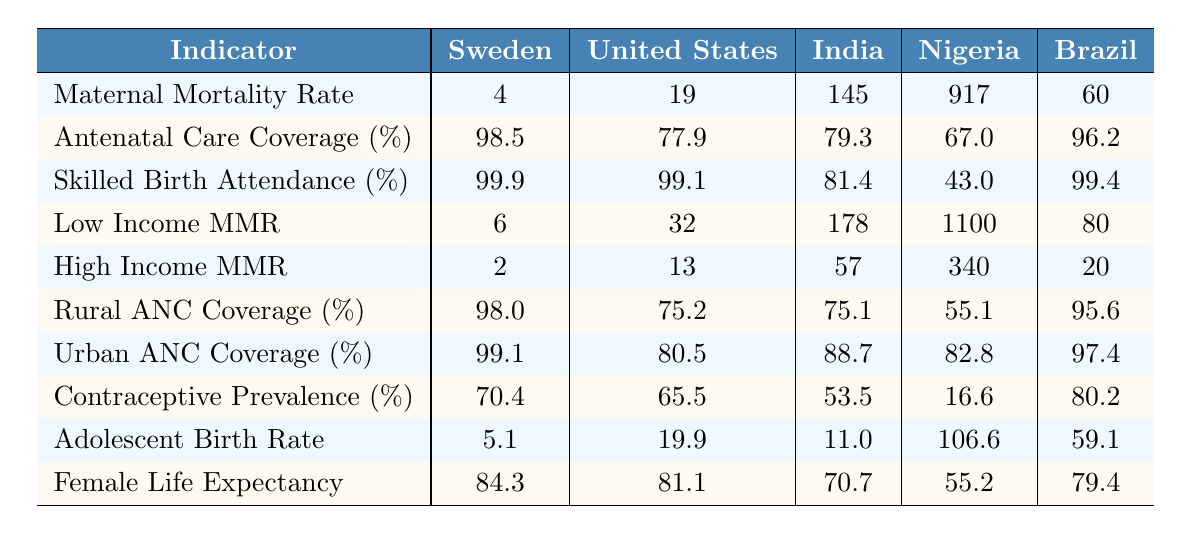What is the maternal mortality rate in Sweden? The table shows that Sweden's maternal mortality rate is listed as 4.
Answer: 4 Which country has the highest antenatal care coverage? Looking at the table, Sweden has the highest antenatal care coverage at 98.5%.
Answer: Sweden What is the percentage of skilled birth attendance in Nigeria? According to the table, Nigeria has a skilled birth attendance percentage of 43.0%.
Answer: 43.0% What is the difference in maternal mortality rate between India and Brazil? India's maternal mortality rate is 145 and Brazil's is 60. The difference is 145 - 60 = 85.
Answer: 85 Is the low-income maternal mortality rate in the United States higher than that in Sweden? The low-income maternal mortality rate in the United States is 32, while Sweden's is 6. Since 32 is greater than 6, the statement is true.
Answer: Yes Which country has the lowest maternal mortality rate, and how does it compare with Nigeria? Sweden has the lowest maternal mortality rate of 4, and Nigeria has a rate of 917. The difference is 917 - 4 = 913, indicating Sweden's rate is much lower by 913.
Answer: Sweden, difference 913 Calculate the average adolescent birth rate across these five countries. The adolescent birth rates are 5.1, 19.9, 11.0, 106.6, and 59.1. Summing these gives 5.1 + 19.9 + 11.0 + 106.6 + 59.1 = 201.7, and dividing by 5 gives an average of 201.7 / 5 = 40.34.
Answer: 40.34 In which country is the contraceptive prevalence lowest, and what is that percentage? The table indicates that India has the lowest contraceptive prevalence at 53.5%.
Answer: India, 53.5% Do rural areas in Nigeria have higher antenatal care coverage than urban areas? Rural ANC coverage in Nigeria is 55.1%, while urban ANC coverage is 82.8%. Since 55.1% is less than 82.8%, this statement is false.
Answer: No What is the correlation between female life expectancy and maternal mortality rate for the countries listed? From the table, an increase in maternal mortality seems to coincide with a decrease in female life expectancy. For example, Nigeria has high maternal mortality (917) and low life expectancy (55.2), while Sweden has low mortality (4) and high life expectancy (84.3), suggesting an inverse relationship.
Answer: Inverse relationship 